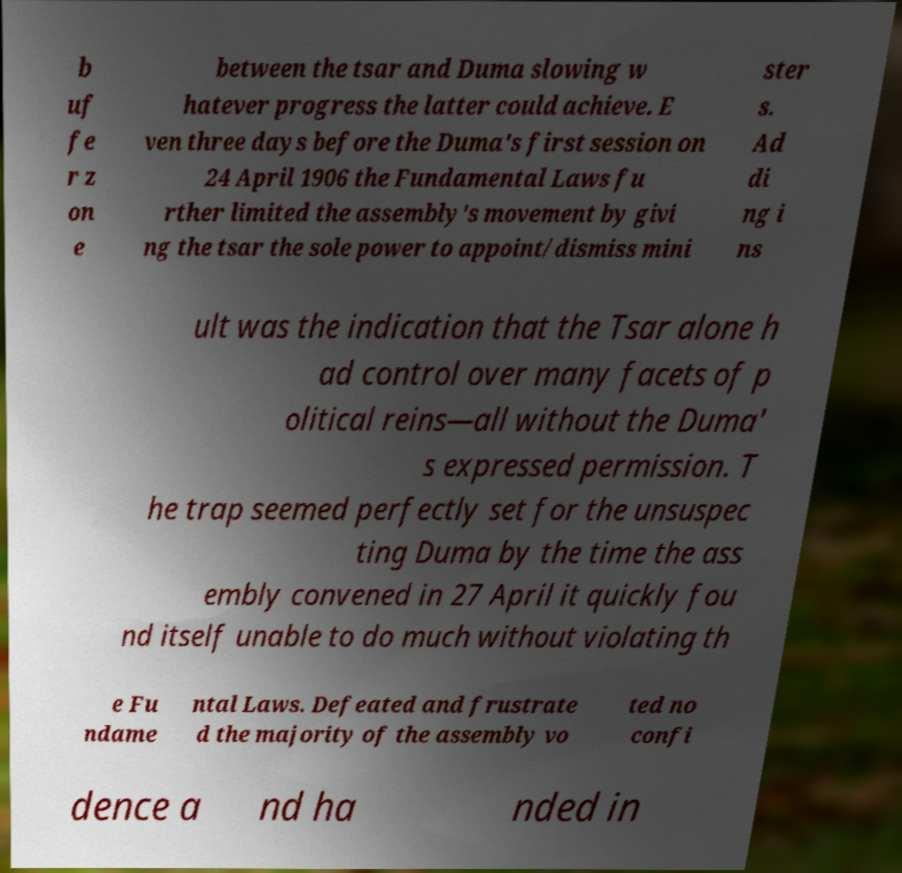I need the written content from this picture converted into text. Can you do that? b uf fe r z on e between the tsar and Duma slowing w hatever progress the latter could achieve. E ven three days before the Duma's first session on 24 April 1906 the Fundamental Laws fu rther limited the assembly's movement by givi ng the tsar the sole power to appoint/dismiss mini ster s. Ad di ng i ns ult was the indication that the Tsar alone h ad control over many facets of p olitical reins—all without the Duma' s expressed permission. T he trap seemed perfectly set for the unsuspec ting Duma by the time the ass embly convened in 27 April it quickly fou nd itself unable to do much without violating th e Fu ndame ntal Laws. Defeated and frustrate d the majority of the assembly vo ted no confi dence a nd ha nded in 